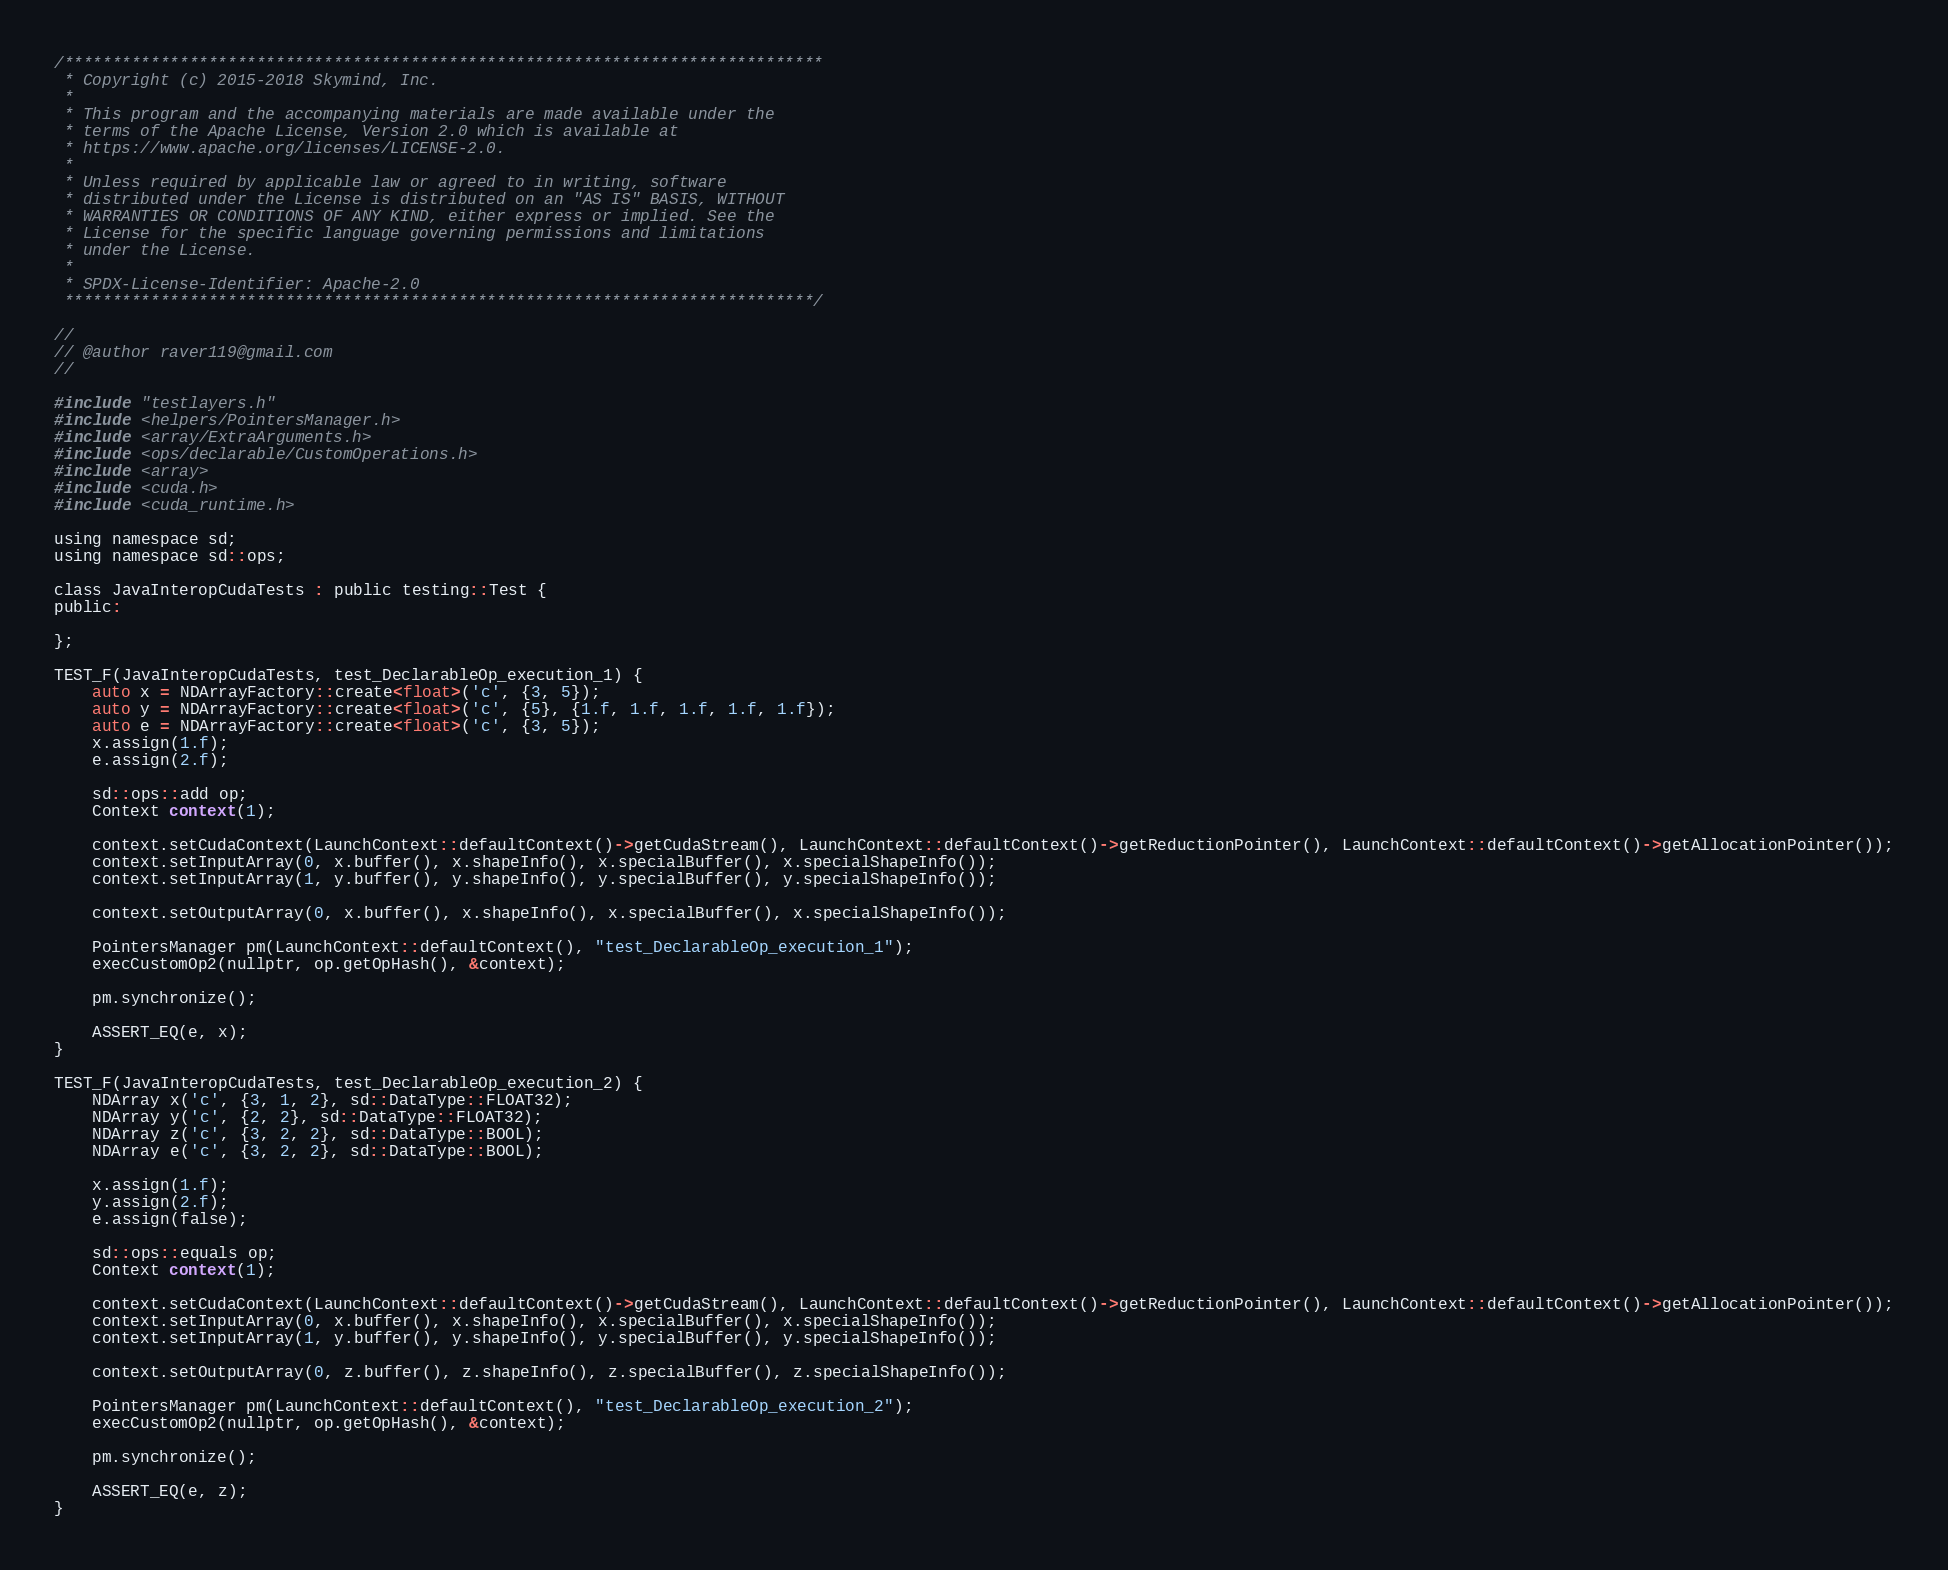Convert code to text. <code><loc_0><loc_0><loc_500><loc_500><_Cuda_>/*******************************************************************************
 * Copyright (c) 2015-2018 Skymind, Inc.
 *
 * This program and the accompanying materials are made available under the
 * terms of the Apache License, Version 2.0 which is available at
 * https://www.apache.org/licenses/LICENSE-2.0.
 *
 * Unless required by applicable law or agreed to in writing, software
 * distributed under the License is distributed on an "AS IS" BASIS, WITHOUT
 * WARRANTIES OR CONDITIONS OF ANY KIND, either express or implied. See the
 * License for the specific language governing permissions and limitations
 * under the License.
 *
 * SPDX-License-Identifier: Apache-2.0
 ******************************************************************************/

//
// @author raver119@gmail.com
//

#include "testlayers.h"
#include <helpers/PointersManager.h>
#include <array/ExtraArguments.h>
#include <ops/declarable/CustomOperations.h>
#include <array>
#include <cuda.h>
#include <cuda_runtime.h>

using namespace sd;
using namespace sd::ops;

class JavaInteropCudaTests : public testing::Test {
public:

};

TEST_F(JavaInteropCudaTests, test_DeclarableOp_execution_1) {
    auto x = NDArrayFactory::create<float>('c', {3, 5});
    auto y = NDArrayFactory::create<float>('c', {5}, {1.f, 1.f, 1.f, 1.f, 1.f});
    auto e = NDArrayFactory::create<float>('c', {3, 5});
    x.assign(1.f);
    e.assign(2.f);

    sd::ops::add op;
    Context context(1);

    context.setCudaContext(LaunchContext::defaultContext()->getCudaStream(), LaunchContext::defaultContext()->getReductionPointer(), LaunchContext::defaultContext()->getAllocationPointer());
    context.setInputArray(0, x.buffer(), x.shapeInfo(), x.specialBuffer(), x.specialShapeInfo());
    context.setInputArray(1, y.buffer(), y.shapeInfo(), y.specialBuffer(), y.specialShapeInfo());

    context.setOutputArray(0, x.buffer(), x.shapeInfo(), x.specialBuffer(), x.specialShapeInfo());

    PointersManager pm(LaunchContext::defaultContext(), "test_DeclarableOp_execution_1");
    execCustomOp2(nullptr, op.getOpHash(), &context);

    pm.synchronize();

    ASSERT_EQ(e, x);
}

TEST_F(JavaInteropCudaTests, test_DeclarableOp_execution_2) {
    NDArray x('c', {3, 1, 2}, sd::DataType::FLOAT32);
    NDArray y('c', {2, 2}, sd::DataType::FLOAT32);
    NDArray z('c', {3, 2, 2}, sd::DataType::BOOL);
    NDArray e('c', {3, 2, 2}, sd::DataType::BOOL);

    x.assign(1.f);
    y.assign(2.f);
    e.assign(false);

    sd::ops::equals op;
    Context context(1);

    context.setCudaContext(LaunchContext::defaultContext()->getCudaStream(), LaunchContext::defaultContext()->getReductionPointer(), LaunchContext::defaultContext()->getAllocationPointer());
    context.setInputArray(0, x.buffer(), x.shapeInfo(), x.specialBuffer(), x.specialShapeInfo());
    context.setInputArray(1, y.buffer(), y.shapeInfo(), y.specialBuffer(), y.specialShapeInfo());

    context.setOutputArray(0, z.buffer(), z.shapeInfo(), z.specialBuffer(), z.specialShapeInfo());

    PointersManager pm(LaunchContext::defaultContext(), "test_DeclarableOp_execution_2");
    execCustomOp2(nullptr, op.getOpHash(), &context);

    pm.synchronize();

    ASSERT_EQ(e, z);
}

</code> 